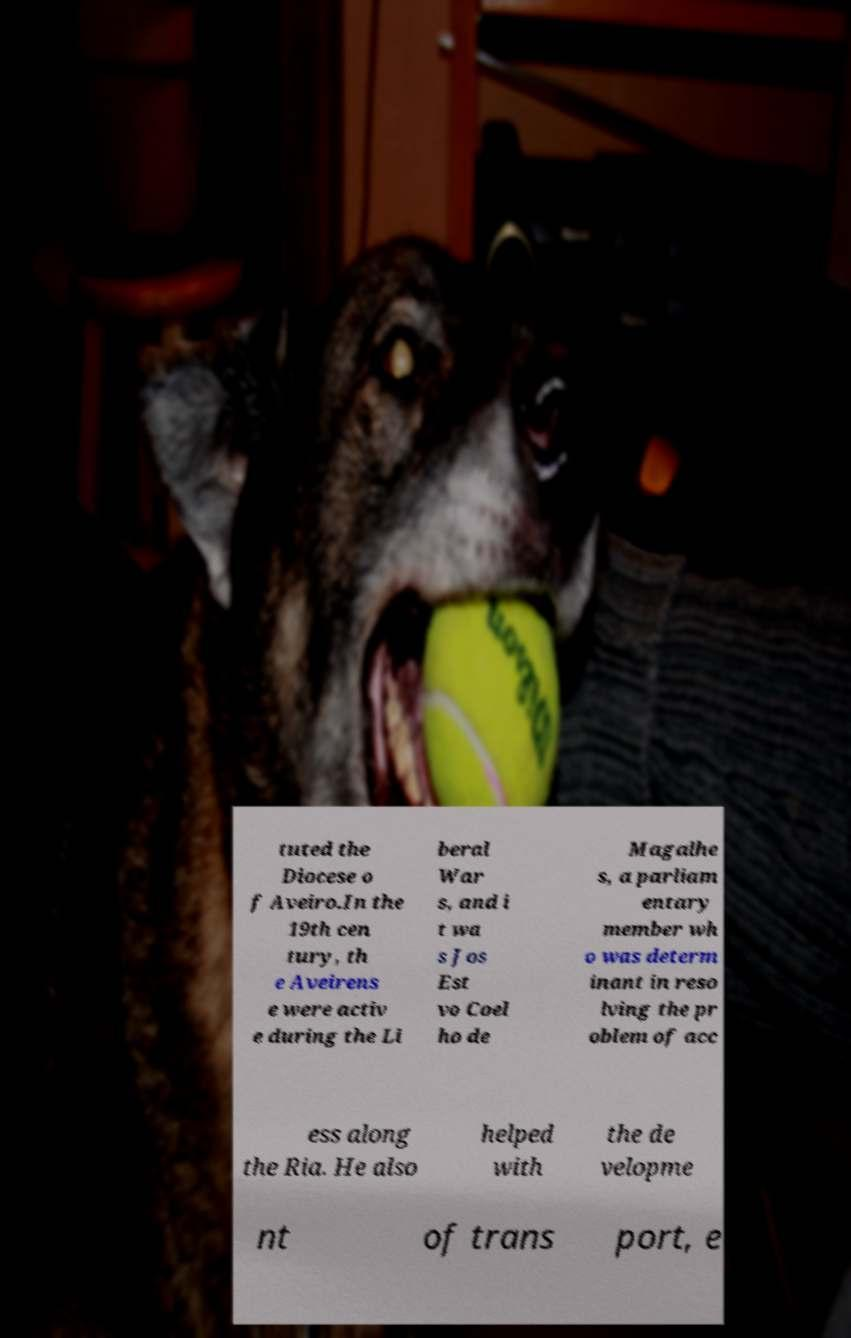For documentation purposes, I need the text within this image transcribed. Could you provide that? tuted the Diocese o f Aveiro.In the 19th cen tury, th e Aveirens e were activ e during the Li beral War s, and i t wa s Jos Est vo Coel ho de Magalhe s, a parliam entary member wh o was determ inant in reso lving the pr oblem of acc ess along the Ria. He also helped with the de velopme nt of trans port, e 